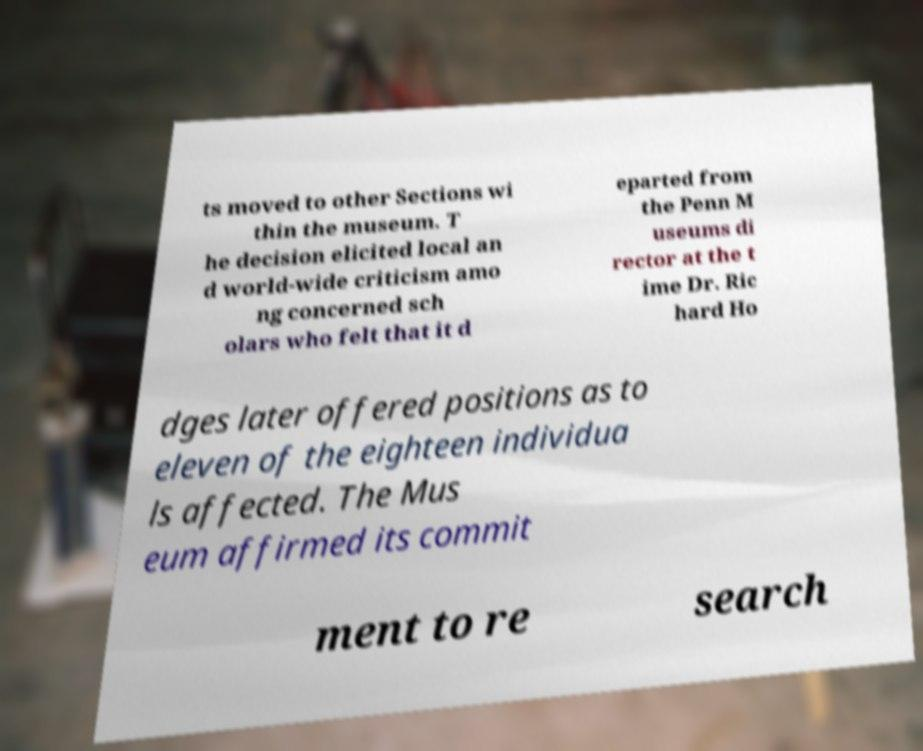There's text embedded in this image that I need extracted. Can you transcribe it verbatim? ts moved to other Sections wi thin the museum. T he decision elicited local an d world-wide criticism amo ng concerned sch olars who felt that it d eparted from the Penn M useums di rector at the t ime Dr. Ric hard Ho dges later offered positions as to eleven of the eighteen individua ls affected. The Mus eum affirmed its commit ment to re search 